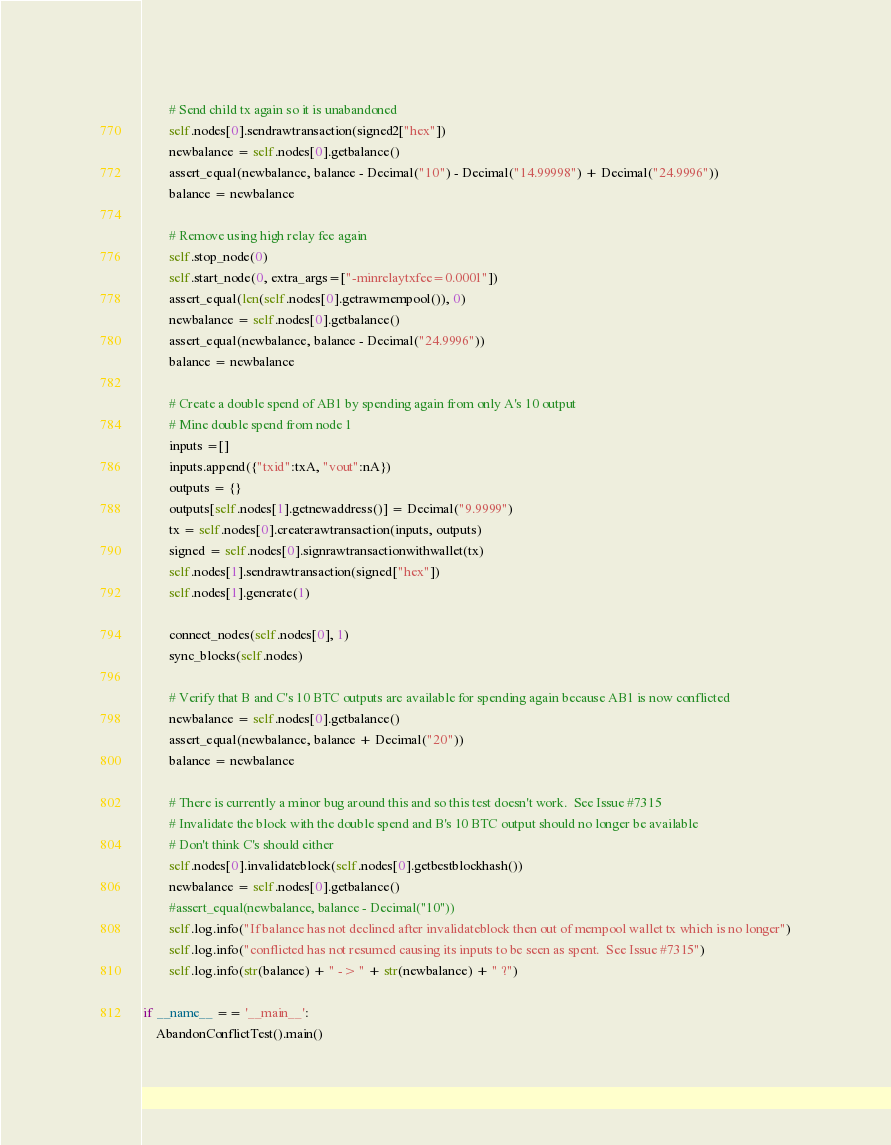Convert code to text. <code><loc_0><loc_0><loc_500><loc_500><_Python_>
        # Send child tx again so it is unabandoned
        self.nodes[0].sendrawtransaction(signed2["hex"])
        newbalance = self.nodes[0].getbalance()
        assert_equal(newbalance, balance - Decimal("10") - Decimal("14.99998") + Decimal("24.9996"))
        balance = newbalance

        # Remove using high relay fee again
        self.stop_node(0)
        self.start_node(0, extra_args=["-minrelaytxfee=0.0001"])
        assert_equal(len(self.nodes[0].getrawmempool()), 0)
        newbalance = self.nodes[0].getbalance()
        assert_equal(newbalance, balance - Decimal("24.9996"))
        balance = newbalance

        # Create a double spend of AB1 by spending again from only A's 10 output
        # Mine double spend from node 1
        inputs =[]
        inputs.append({"txid":txA, "vout":nA})
        outputs = {}
        outputs[self.nodes[1].getnewaddress()] = Decimal("9.9999")
        tx = self.nodes[0].createrawtransaction(inputs, outputs)
        signed = self.nodes[0].signrawtransactionwithwallet(tx)
        self.nodes[1].sendrawtransaction(signed["hex"])
        self.nodes[1].generate(1)

        connect_nodes(self.nodes[0], 1)
        sync_blocks(self.nodes)

        # Verify that B and C's 10 BTC outputs are available for spending again because AB1 is now conflicted
        newbalance = self.nodes[0].getbalance()
        assert_equal(newbalance, balance + Decimal("20"))
        balance = newbalance

        # There is currently a minor bug around this and so this test doesn't work.  See Issue #7315
        # Invalidate the block with the double spend and B's 10 BTC output should no longer be available
        # Don't think C's should either
        self.nodes[0].invalidateblock(self.nodes[0].getbestblockhash())
        newbalance = self.nodes[0].getbalance()
        #assert_equal(newbalance, balance - Decimal("10"))
        self.log.info("If balance has not declined after invalidateblock then out of mempool wallet tx which is no longer")
        self.log.info("conflicted has not resumed causing its inputs to be seen as spent.  See Issue #7315")
        self.log.info(str(balance) + " -> " + str(newbalance) + " ?")

if __name__ == '__main__':
    AbandonConflictTest().main()
</code> 